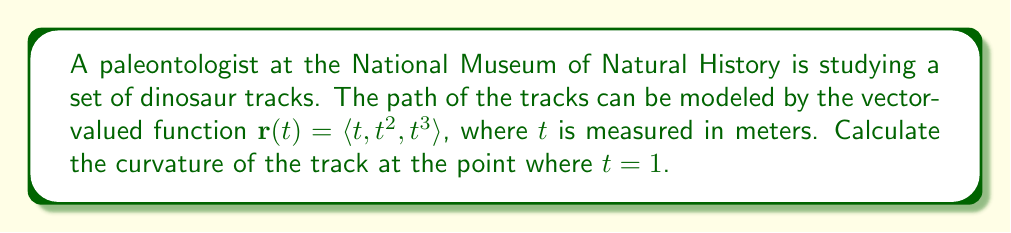Can you answer this question? To find the curvature of the dinosaur track, we'll use the formula for curvature of a space curve:

$$\kappa = \frac{|\mathbf{r}'(t) \times \mathbf{r}''(t)|}{|\mathbf{r}'(t)|^3}$$

Step 1: Calculate $\mathbf{r}'(t)$
$$\mathbf{r}'(t) = \langle 1, 2t, 3t^2 \rangle$$

Step 2: Calculate $\mathbf{r}''(t)$
$$\mathbf{r}''(t) = \langle 0, 2, 6t \rangle$$

Step 3: Calculate $\mathbf{r}'(t) \times \mathbf{r}''(t)$
$$\mathbf{r}'(t) \times \mathbf{r}''(t) = \begin{vmatrix} 
\mathbf{i} & \mathbf{j} & \mathbf{k} \\
1 & 2t & 3t^2 \\
0 & 2 & 6t
\end{vmatrix} = \langle 6t^2 - 6t^2, -6t, 2 \rangle = \langle 0, -6t, 2 \rangle$$

Step 4: Calculate $|\mathbf{r}'(t) \times \mathbf{r}''(t)|$
$$|\mathbf{r}'(t) \times \mathbf{r}''(t)| = \sqrt{0^2 + (-6t)^2 + 2^2} = \sqrt{36t^2 + 4}$$

Step 5: Calculate $|\mathbf{r}'(t)|$
$$|\mathbf{r}'(t)| = \sqrt{1^2 + (2t)^2 + (3t^2)^2} = \sqrt{1 + 4t^2 + 9t^4}$$

Step 6: Apply the curvature formula at $t = 1$
$$\kappa = \frac{\sqrt{36(1)^2 + 4}}{(\sqrt{1 + 4(1)^2 + 9(1)^4})^3} = \frac{\sqrt{40}}{(\sqrt{14})^3}$$

Step 7: Simplify the result
$$\kappa = \frac{\sqrt{40}}{14\sqrt{14}} = \frac{2\sqrt{10}}{14\sqrt{14}}$$
Answer: $\frac{2\sqrt{10}}{14\sqrt{14}}$ 